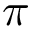Convert formula to latex. <formula><loc_0><loc_0><loc_500><loc_500>\pi</formula> 